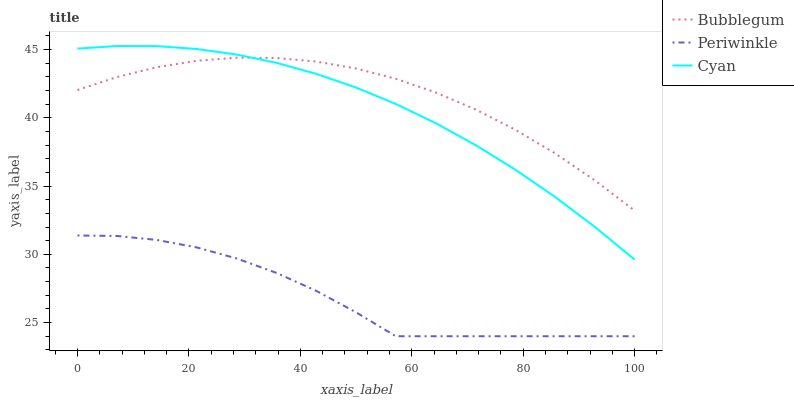Does Periwinkle have the minimum area under the curve?
Answer yes or no. Yes. Does Bubblegum have the maximum area under the curve?
Answer yes or no. Yes. Does Bubblegum have the minimum area under the curve?
Answer yes or no. No. Does Periwinkle have the maximum area under the curve?
Answer yes or no. No. Is Cyan the smoothest?
Answer yes or no. Yes. Is Periwinkle the roughest?
Answer yes or no. Yes. Is Bubblegum the smoothest?
Answer yes or no. No. Is Bubblegum the roughest?
Answer yes or no. No. Does Bubblegum have the lowest value?
Answer yes or no. No. Does Cyan have the highest value?
Answer yes or no. Yes. Does Bubblegum have the highest value?
Answer yes or no. No. Is Periwinkle less than Bubblegum?
Answer yes or no. Yes. Is Bubblegum greater than Periwinkle?
Answer yes or no. Yes. Does Cyan intersect Bubblegum?
Answer yes or no. Yes. Is Cyan less than Bubblegum?
Answer yes or no. No. Is Cyan greater than Bubblegum?
Answer yes or no. No. Does Periwinkle intersect Bubblegum?
Answer yes or no. No. 